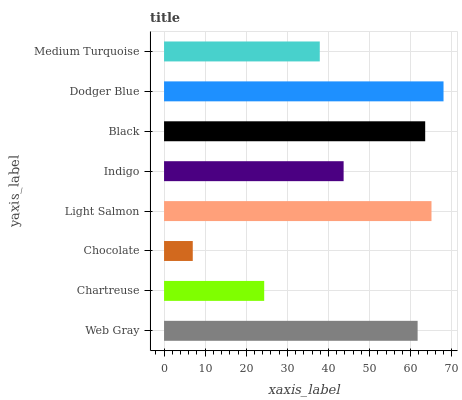Is Chocolate the minimum?
Answer yes or no. Yes. Is Dodger Blue the maximum?
Answer yes or no. Yes. Is Chartreuse the minimum?
Answer yes or no. No. Is Chartreuse the maximum?
Answer yes or no. No. Is Web Gray greater than Chartreuse?
Answer yes or no. Yes. Is Chartreuse less than Web Gray?
Answer yes or no. Yes. Is Chartreuse greater than Web Gray?
Answer yes or no. No. Is Web Gray less than Chartreuse?
Answer yes or no. No. Is Web Gray the high median?
Answer yes or no. Yes. Is Indigo the low median?
Answer yes or no. Yes. Is Dodger Blue the high median?
Answer yes or no. No. Is Web Gray the low median?
Answer yes or no. No. 